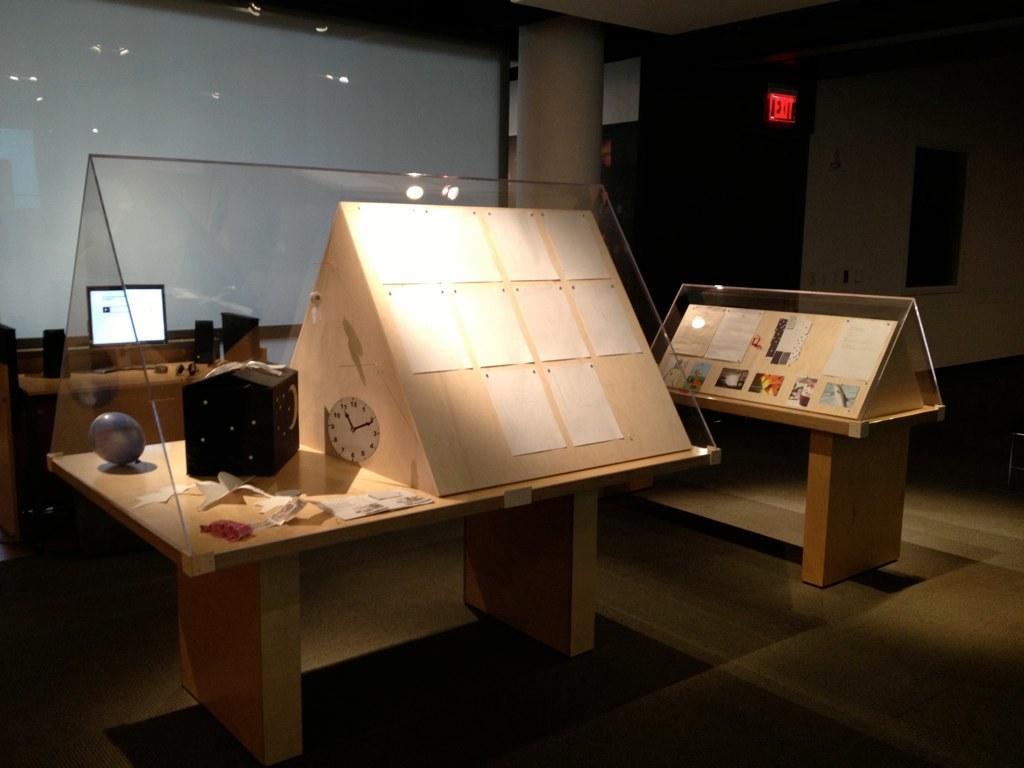Please provide a concise description of this image. In the image there is a clock and pyramid,ball and some papers inside a glass on a table and beside it there is another table with papers inside a glass on a pyramid, in the back there is wall with computer and speakers in front it on a table, on the right side there is an exit door. 